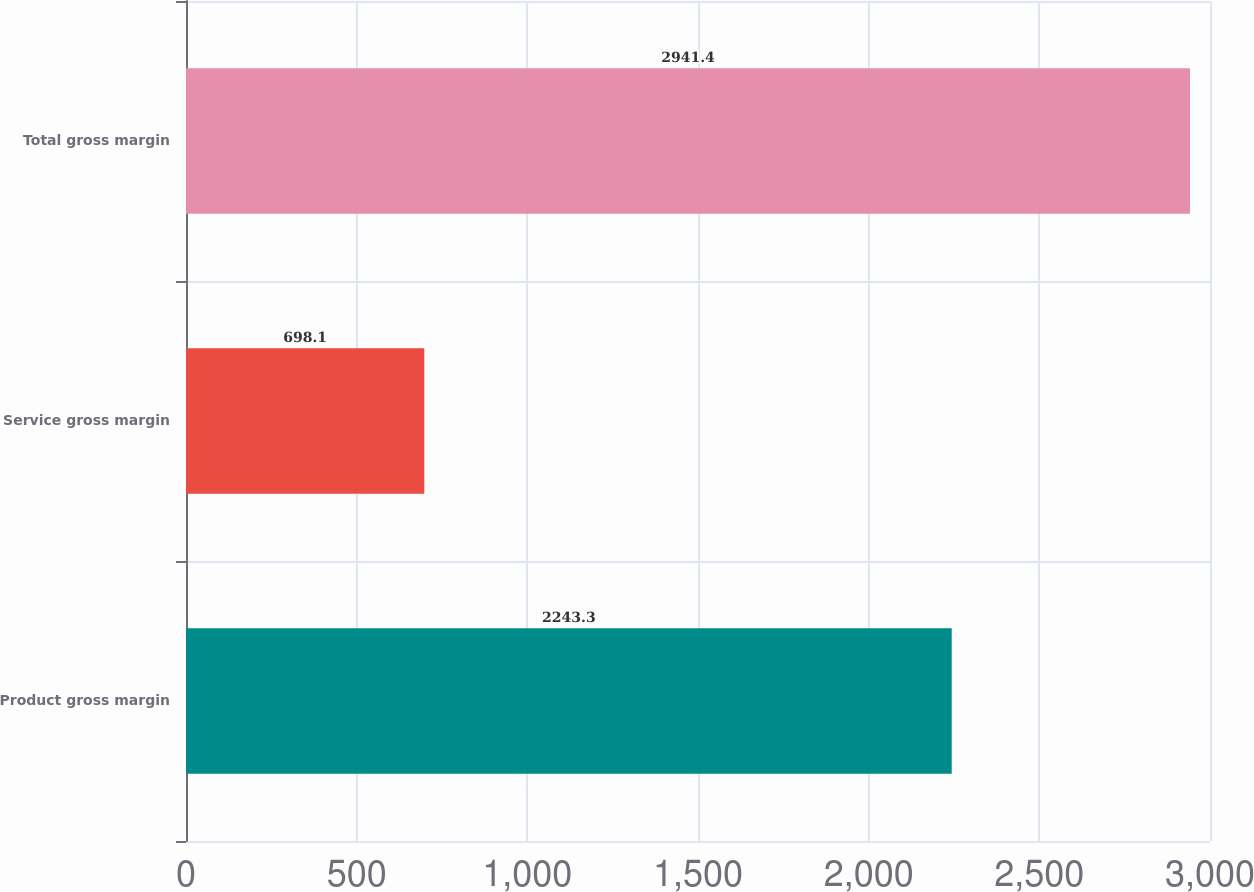<chart> <loc_0><loc_0><loc_500><loc_500><bar_chart><fcel>Product gross margin<fcel>Service gross margin<fcel>Total gross margin<nl><fcel>2243.3<fcel>698.1<fcel>2941.4<nl></chart> 